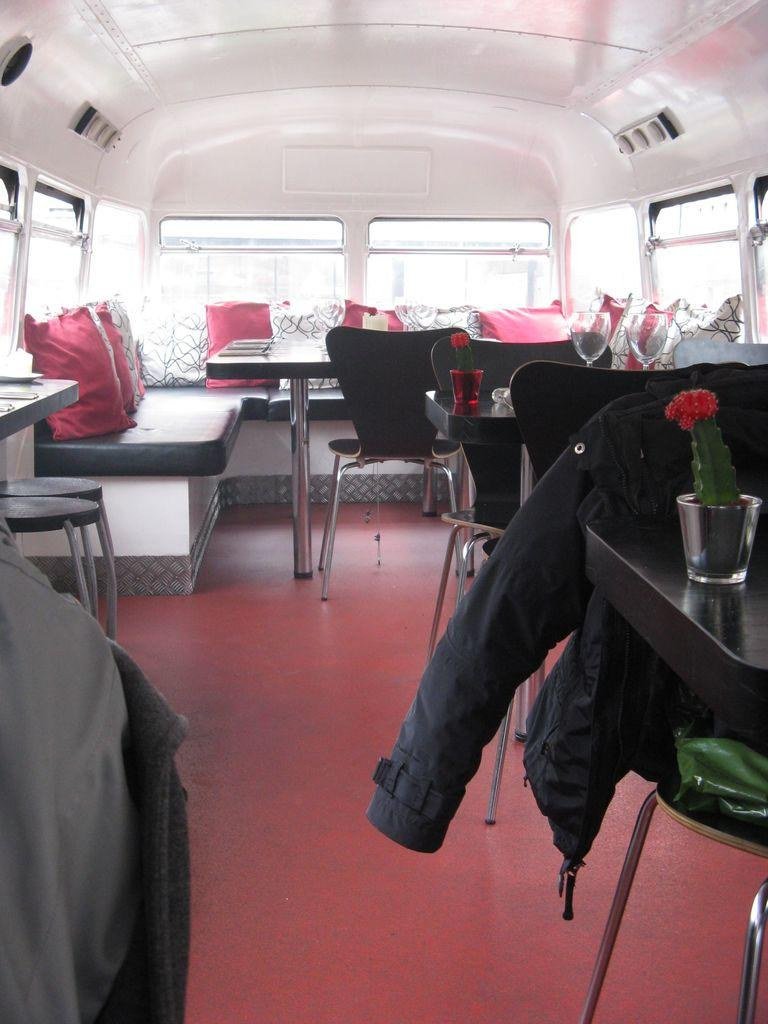What type of furniture is present in the image? There are chairs and tables in the image. What objects can be seen on the tables? There are glasses on the table in the image. How is the jacket positioned in the image? The jacket is on a chair in the image. What part of the room can be seen in the image? The floor is visible in the image. What thing is planning a voyage in the image? There is no thing or object in the image that is planning a voyage. 